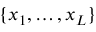<formula> <loc_0><loc_0><loc_500><loc_500>\{ x _ { 1 } , \dots , x _ { L } \}</formula> 